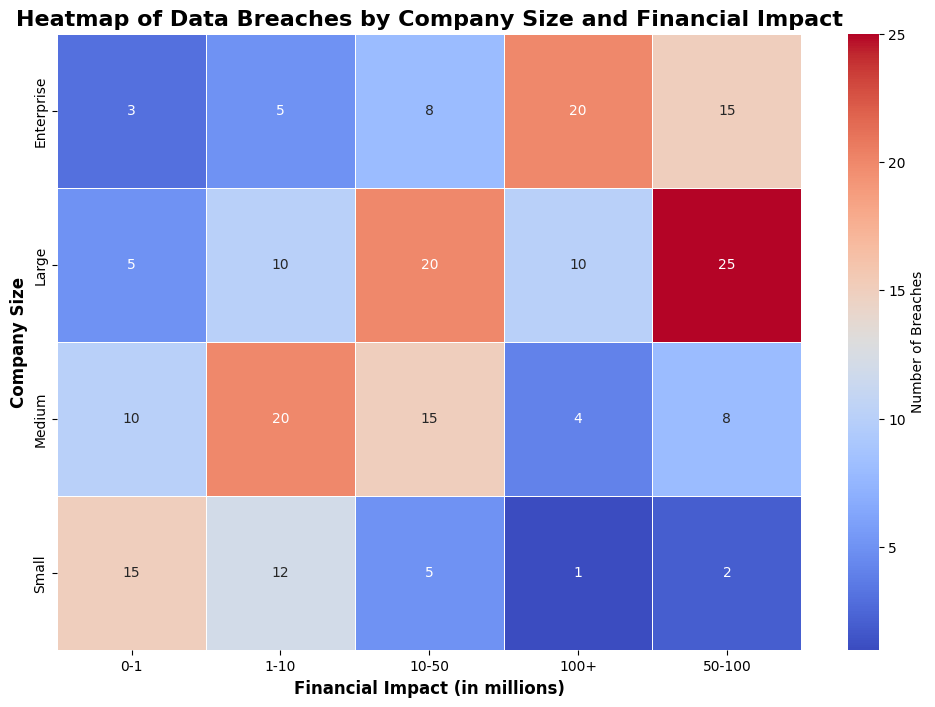Which company size had the highest number of data breaches with a financial impact of 100+ million? The color intensity and the annotated number indicate the highest figure. Enterprise companies show the highest number with 20 breaches in the 100+ million category.
Answer: Enterprise What is the total number of breaches for medium-sized companies across all financial impact categories? Sum the annotated numbers for medium-sized companies across all categories. The values are 10, 20, 15, 8, and 4. Therefore, 10 + 20 + 15 + 8 + 4 = 57.
Answer: 57 Comparing small and large companies, which had more breaches in the 10-50 million financial impact category, and by how much? Check the annotated numbers in the 10-50 million category for both company sizes. Small companies had 5 breaches, and large companies had 20. Therefore, large companies had 20 - 5 = 15 more breaches than small companies.
Answer: Large, by 15 Which financial impact category has the most uniform distribution of breaches across different company sizes? Look for the financial impact category where the visual map shows similar numbers across different company sizes. The 1-10 million category has the most uniform distribution, with numbers ranging from 5 to 20 but the differences are relatively low compared to other categories.
Answer: 1-10 million What is the difference in the number of breaches between small and enterprise companies at the lowest financial impact category (0-1 million)? Check the annotated numbers for the 0-1 million category. Small companies had 15 breaches, and enterprise companies had 3. Therefore, the difference is 15 - 3 = 12.
Answer: 12 In which financial impact category do medium and large companies show the greatest disparity in the number of breaches? Compare the numbers in each financial impact category for medium and large companies. The 50-100 million category has the greatest disparity; medium has 8 breaches while large has 25 breaches, a difference of 17.
Answer: 50-100 million Which visual attribute changes most noticeably as financial impact increases from 0-1 million to 100+ million for enterprise companies? Observe the gradient changes in the heatmap for enterprise companies across financial impact categories. The number of breaches increases and the color intensity of the heatmap cell becomes darker from 0-1 (3 breaches, lighter) to 100+ (20 breaches, darker).
Answer: Color intensity What's the average number of breaches for large companies considering all financial impact categories? Sum all breaches for large companies and divide by the number of categories. The values are 5, 10, 20, 25, and 10. Therefore, (5 + 10 + 20 + 25 + 10) / 5 = 14.
Answer: 14 Which company size category shows the highest variability in the number of breaches across all financial impact categories? Examine the variability in numbers within each company size. The large company size shows the highest variability with numbers ranging from 5 to 25, indicating wide differences in breaches across financial impact categories.
Answer: Large How does the number of breaches for medium companies in the financial impact category 10-50 million compare to the sum of breaches for small companies in the categories 50-100 million and 100+ million? Check the figures: Medium companies have 15 breaches in the 10-50 million category. Small companies have 2 + 1 = 3 breaches in the 50-100 million and 100+ million categories respectively. Therefore, 15 is significantly higher than 3.
Answer: Much higher for Medium companies 